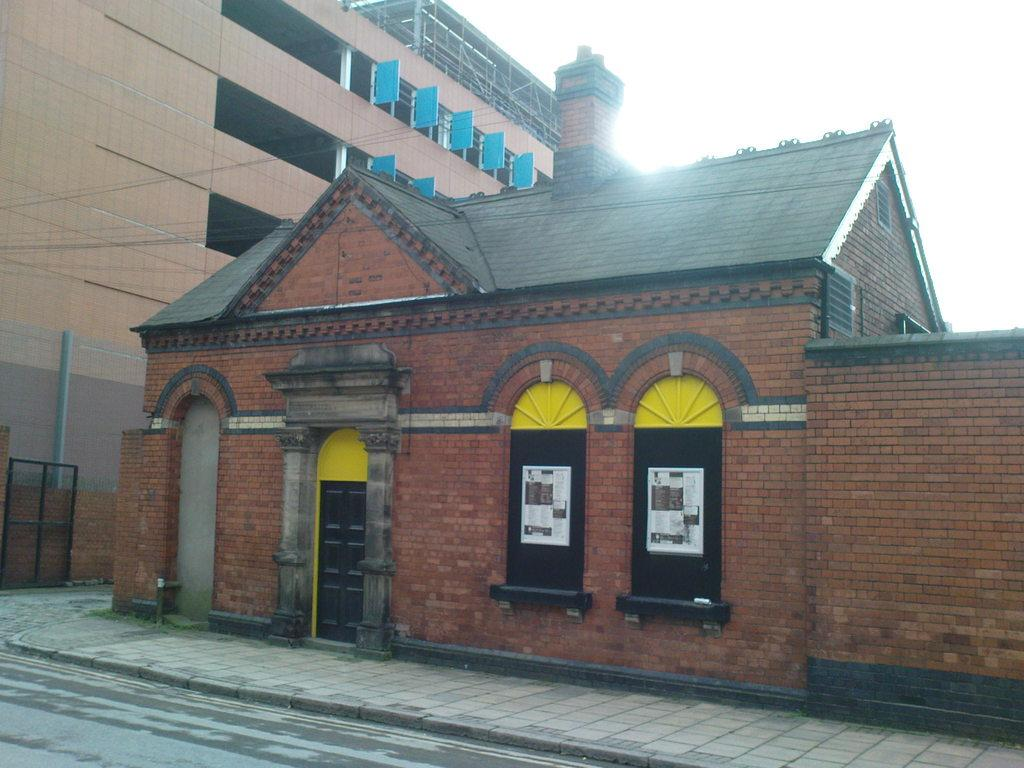What is the main subject in the center of the image? There is a house in the center of the image. What other structure can be seen on the left side of the image? There is a building on the left side of the image. Where is the coat rack located in the image? There is no coat rack present in the image. What type of books can be seen on the tramp in the image? There is no tramp or books present in the image. 